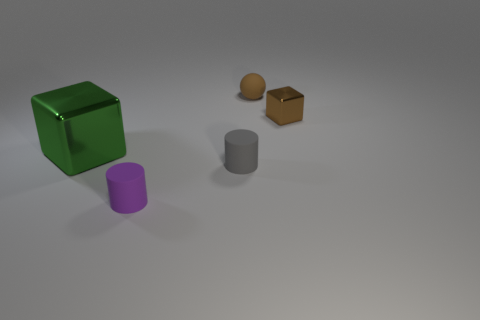Is there anything else that is the same size as the green object?
Provide a succinct answer. No. Is the material of the cube on the right side of the green thing the same as the small brown ball that is to the right of the gray cylinder?
Make the answer very short. No. Are there an equal number of small brown objects in front of the tiny purple rubber thing and small purple matte objects that are behind the green cube?
Make the answer very short. Yes. What number of small objects are the same material as the small purple cylinder?
Offer a terse response. 2. There is a small shiny object that is the same color as the rubber sphere; what is its shape?
Your response must be concise. Cube. How big is the thing that is on the right side of the small brown object that is behind the tiny metallic cube?
Keep it short and to the point. Small. There is a brown shiny object right of the small gray thing; is its shape the same as the tiny matte object behind the green thing?
Provide a short and direct response. No. Are there an equal number of big green blocks that are on the right side of the small brown metal cube and large green metal cubes?
Provide a short and direct response. No. What color is the other shiny object that is the same shape as the big object?
Keep it short and to the point. Brown. Is the block in front of the brown shiny cube made of the same material as the gray object?
Make the answer very short. No. 